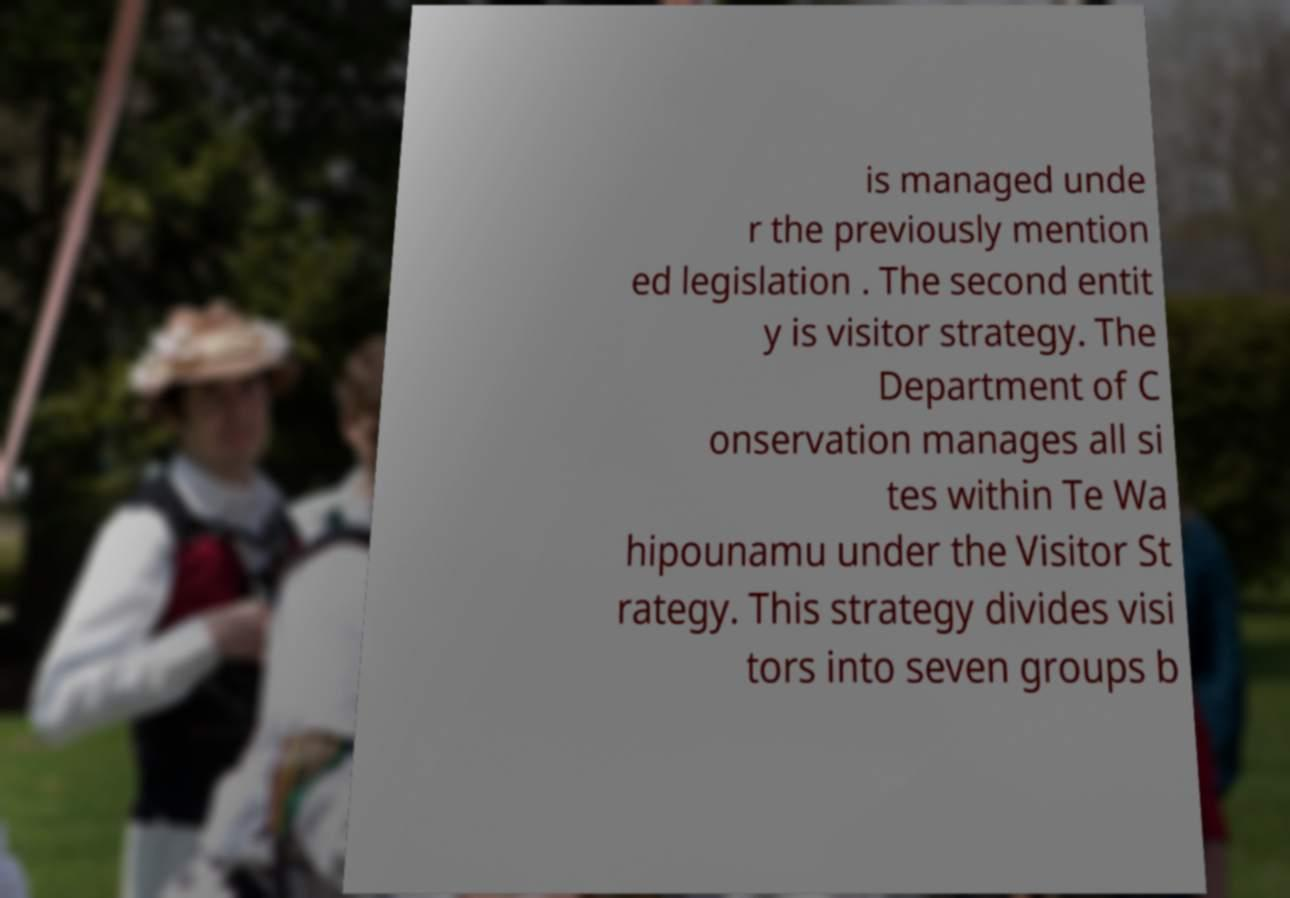What messages or text are displayed in this image? I need them in a readable, typed format. is managed unde r the previously mention ed legislation . The second entit y is visitor strategy. The Department of C onservation manages all si tes within Te Wa hipounamu under the Visitor St rategy. This strategy divides visi tors into seven groups b 